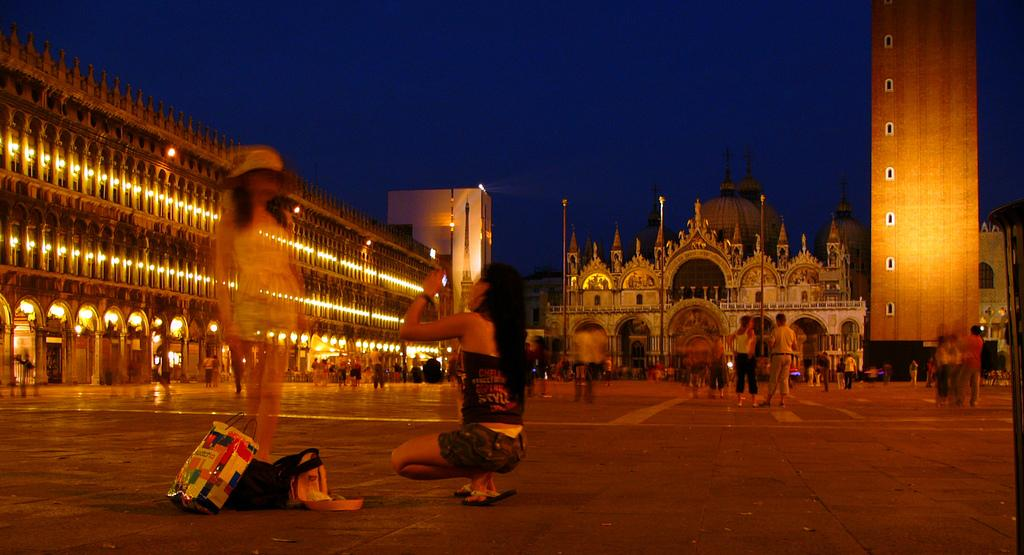How many ladies are present in the image? There are two ladies in the image. What is on the floor near the ladies? There are bags on the floor. What can be observed about the floor in the image? There are many people standing on the floor. What is visible in the background of the image? There are buildings with lights in the background of the image. What type of balls are being used in the action scene in the image? There is no action scene or balls present in the image. 